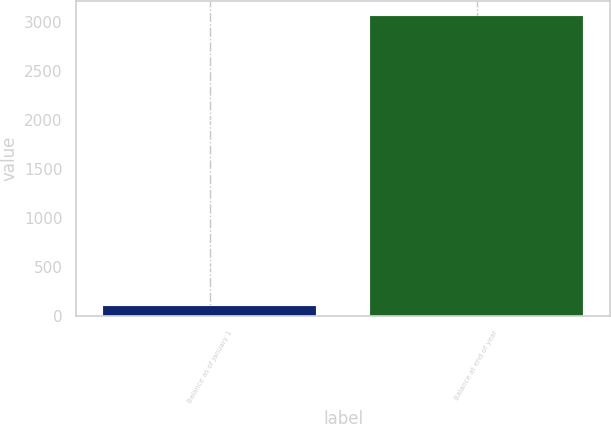Convert chart to OTSL. <chart><loc_0><loc_0><loc_500><loc_500><bar_chart><fcel>Balance as of January 1<fcel>Balance at end of year<nl><fcel>110.5<fcel>3064.4<nl></chart> 